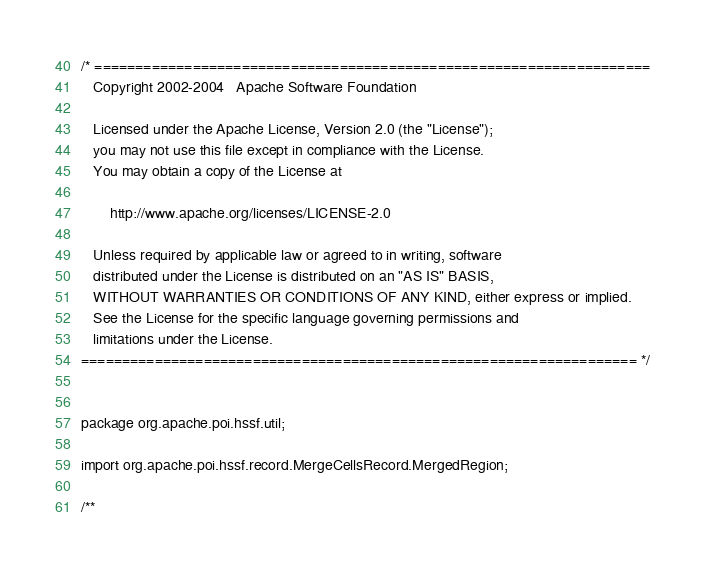<code> <loc_0><loc_0><loc_500><loc_500><_Java_>/* ====================================================================
   Copyright 2002-2004   Apache Software Foundation

   Licensed under the Apache License, Version 2.0 (the "License");
   you may not use this file except in compliance with the License.
   You may obtain a copy of the License at

       http://www.apache.org/licenses/LICENSE-2.0

   Unless required by applicable law or agreed to in writing, software
   distributed under the License is distributed on an "AS IS" BASIS,
   WITHOUT WARRANTIES OR CONDITIONS OF ANY KIND, either express or implied.
   See the License for the specific language governing permissions and
   limitations under the License.
==================================================================== */


package org.apache.poi.hssf.util;

import org.apache.poi.hssf.record.MergeCellsRecord.MergedRegion;

/**</code> 